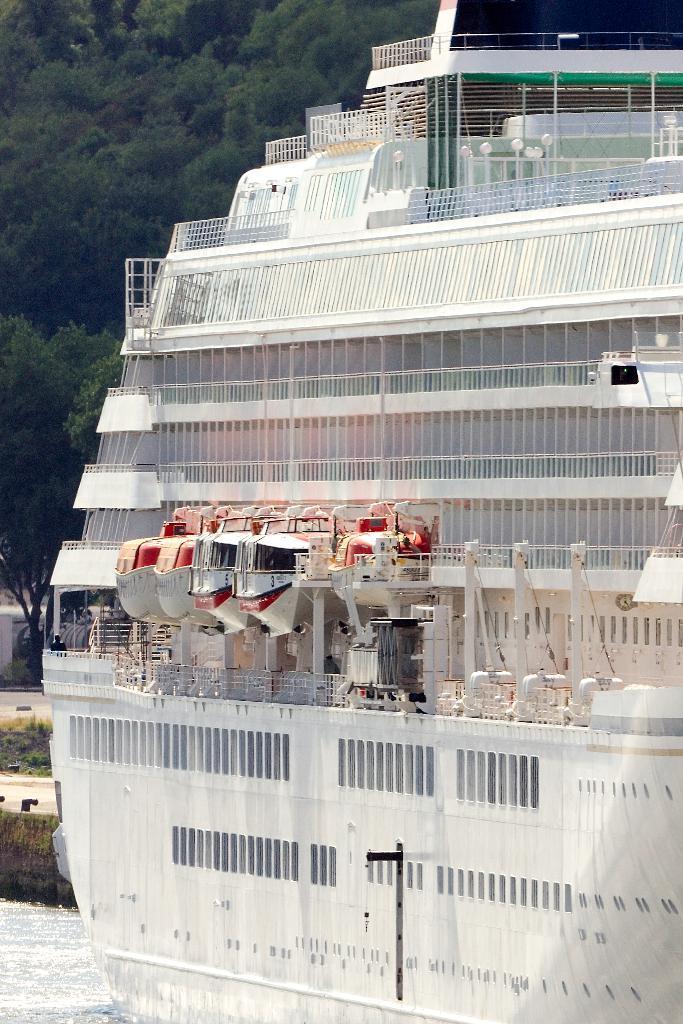In one or two sentences, can you explain what this image depicts? In this image we can see a ship which is of white color and at the background of the image there are some trees. 